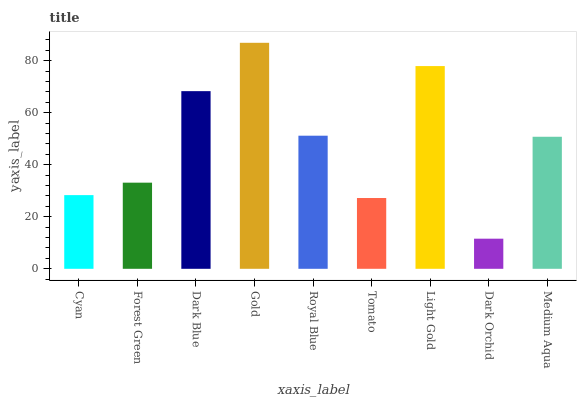Is Forest Green the minimum?
Answer yes or no. No. Is Forest Green the maximum?
Answer yes or no. No. Is Forest Green greater than Cyan?
Answer yes or no. Yes. Is Cyan less than Forest Green?
Answer yes or no. Yes. Is Cyan greater than Forest Green?
Answer yes or no. No. Is Forest Green less than Cyan?
Answer yes or no. No. Is Medium Aqua the high median?
Answer yes or no. Yes. Is Medium Aqua the low median?
Answer yes or no. Yes. Is Tomato the high median?
Answer yes or no. No. Is Dark Orchid the low median?
Answer yes or no. No. 